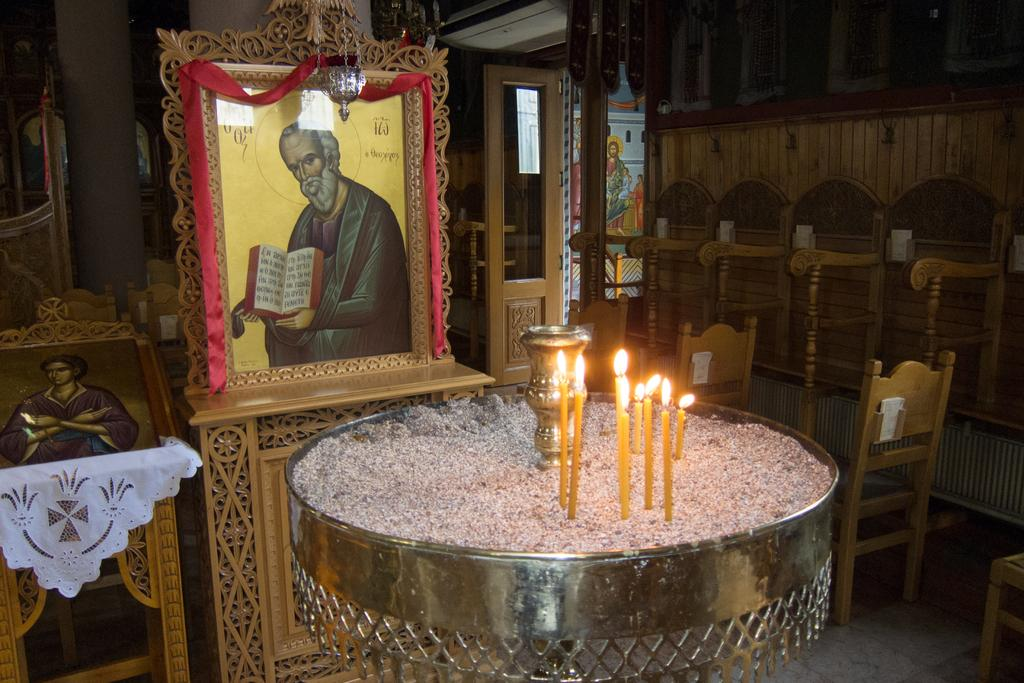What objects can be seen in the image that provide light? There is a light source in the image. What type of objects are used for displaying photos? There are photo frames in the image. What type of furniture is present in the image? There are wooden chairs in the image. What architectural feature is present in the image that allows for entering or exiting a room? There is a door in the image. How would you describe the lighting conditions in the image? The background of the image is dark. What type of alley can be seen in the image? There is no alley present in the image. What type of pump is used to drive the candles in the image? There are no pumps or driving mechanisms present in the image; the candles are likely lit by the light source. 